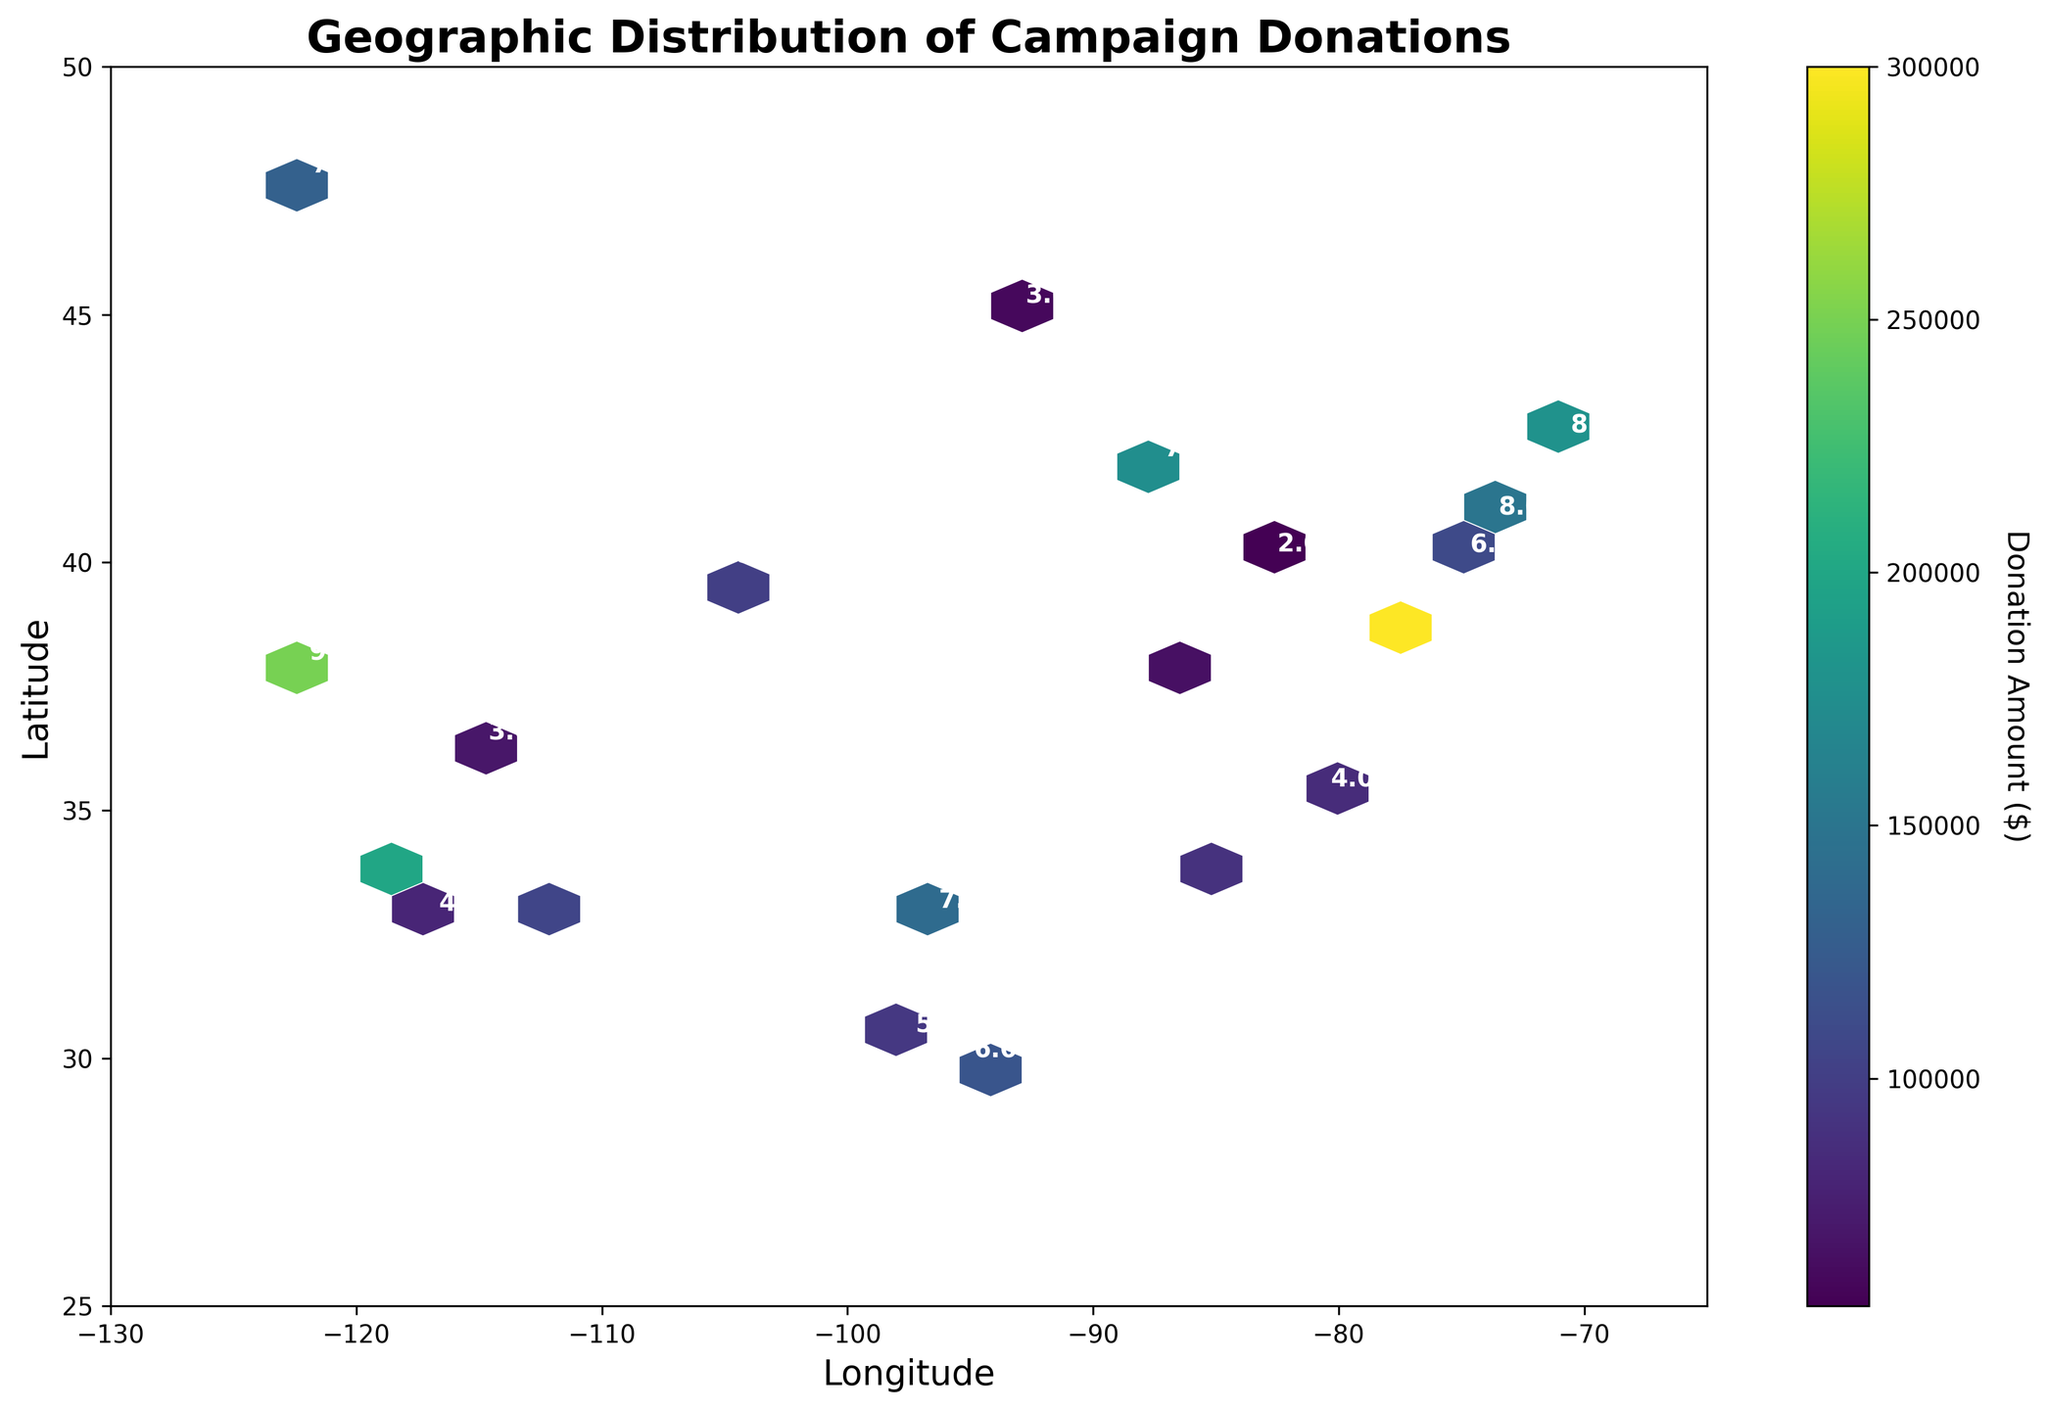what is the title of the figure? The title is displayed prominently at the top of the figure and is usually written in a larger, bold font to summarize the main focus of the figure. Here, the title indicates the content of the plot.
Answer: Geographic Distribution of Campaign Donations what are the labels of the x and y axes? The labels for the axes are typically found at the end of each axis, helping to indicate what each axis represents. In this case, they provide geographical coordinates.
Answer: Longitude and Latitude which region has the highest concentration of donations? By observing the color intensity in different hexagons, the region with the most intense color represents the highest concentration. Here, intense color is around the Washington, D.C., area.
Answer: Washington, D.C how many main clusters of high donation concentrations can be identified? By examining the distribution of hexagons with intense colors, we can count the number of distinct clusters where the concentration of donations is high.
Answer: 4 in which city do we find the donation amount annotated with a concentration level of 10? Annotations in the figure mark the concentration levels, and the associated geographical locations can be identified accordingly.
Answer: Washington, D.C how does the donation amount in Los Angeles (identified with a concentration level of 9) compare to that in New York (identified with a concentration level of 8)? By comparing the colors and the donation amounts given in the legend for Los Angeles and New York, we notice that donations in Los Angeles are higher.
Answer: Higher what is the range of latitudes covered in this figure? The range is derived by observing the lower and upper limits of the y-axis, representing latitude values in the plot.
Answer: 25 to 50 what is the median concentration level across all annotated data points? To find the median, list all concentration levels, order them, and find the middle value. Here the levels are 8, 9, 7, 6, 10, 8, 5, 6, 4, 9, 3, 7, 5, 3, 4, 5, 2, 3, 6, 7. The median value is the middle in this ordered series.
Answer: 6.5 which city has the lowest donation amount, and what is its concentration level? Look for the city with the lightest color hexagon and lowest annotated donation amount. The concentration level annotated will confirm.
Answer: Columbus, 2 what does the color bar represent and how do its values range? The color bar, usually on the side of a hexbin plot, indicates the amount of donation through its gradient, detailing the minimum and maximum bounds for visual interpretation.
Answer: Donation Amount ($), ranges from minimum to maximum donations on the plot 